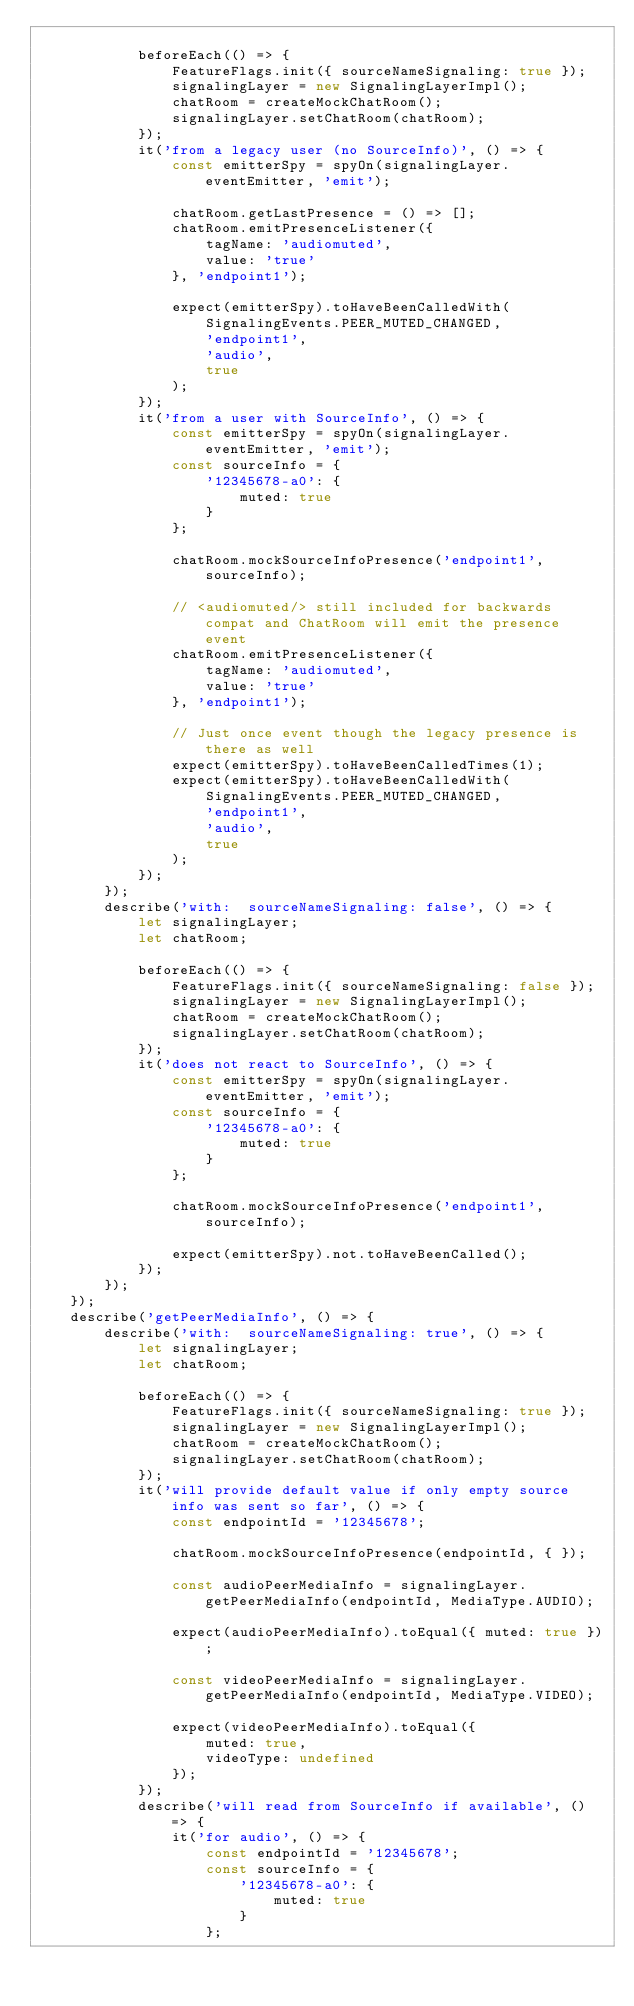<code> <loc_0><loc_0><loc_500><loc_500><_JavaScript_>
            beforeEach(() => {
                FeatureFlags.init({ sourceNameSignaling: true });
                signalingLayer = new SignalingLayerImpl();
                chatRoom = createMockChatRoom();
                signalingLayer.setChatRoom(chatRoom);
            });
            it('from a legacy user (no SourceInfo)', () => {
                const emitterSpy = spyOn(signalingLayer.eventEmitter, 'emit');

                chatRoom.getLastPresence = () => [];
                chatRoom.emitPresenceListener({
                    tagName: 'audiomuted',
                    value: 'true'
                }, 'endpoint1');

                expect(emitterSpy).toHaveBeenCalledWith(
                    SignalingEvents.PEER_MUTED_CHANGED,
                    'endpoint1',
                    'audio',
                    true
                );
            });
            it('from a user with SourceInfo', () => {
                const emitterSpy = spyOn(signalingLayer.eventEmitter, 'emit');
                const sourceInfo = {
                    '12345678-a0': {
                        muted: true
                    }
                };

                chatRoom.mockSourceInfoPresence('endpoint1', sourceInfo);

                // <audiomuted/> still included for backwards compat and ChatRoom will emit the presence event
                chatRoom.emitPresenceListener({
                    tagName: 'audiomuted',
                    value: 'true'
                }, 'endpoint1');

                // Just once event though the legacy presence is there as well
                expect(emitterSpy).toHaveBeenCalledTimes(1);
                expect(emitterSpy).toHaveBeenCalledWith(
                    SignalingEvents.PEER_MUTED_CHANGED,
                    'endpoint1',
                    'audio',
                    true
                );
            });
        });
        describe('with:  sourceNameSignaling: false', () => {
            let signalingLayer;
            let chatRoom;

            beforeEach(() => {
                FeatureFlags.init({ sourceNameSignaling: false });
                signalingLayer = new SignalingLayerImpl();
                chatRoom = createMockChatRoom();
                signalingLayer.setChatRoom(chatRoom);
            });
            it('does not react to SourceInfo', () => {
                const emitterSpy = spyOn(signalingLayer.eventEmitter, 'emit');
                const sourceInfo = {
                    '12345678-a0': {
                        muted: true
                    }
                };

                chatRoom.mockSourceInfoPresence('endpoint1', sourceInfo);

                expect(emitterSpy).not.toHaveBeenCalled();
            });
        });
    });
    describe('getPeerMediaInfo', () => {
        describe('with:  sourceNameSignaling: true', () => {
            let signalingLayer;
            let chatRoom;

            beforeEach(() => {
                FeatureFlags.init({ sourceNameSignaling: true });
                signalingLayer = new SignalingLayerImpl();
                chatRoom = createMockChatRoom();
                signalingLayer.setChatRoom(chatRoom);
            });
            it('will provide default value if only empty source info was sent so far', () => {
                const endpointId = '12345678';

                chatRoom.mockSourceInfoPresence(endpointId, { });

                const audioPeerMediaInfo = signalingLayer.getPeerMediaInfo(endpointId, MediaType.AUDIO);

                expect(audioPeerMediaInfo).toEqual({ muted: true });

                const videoPeerMediaInfo = signalingLayer.getPeerMediaInfo(endpointId, MediaType.VIDEO);

                expect(videoPeerMediaInfo).toEqual({
                    muted: true,
                    videoType: undefined
                });
            });
            describe('will read from SourceInfo if available', () => {
                it('for audio', () => {
                    const endpointId = '12345678';
                    const sourceInfo = {
                        '12345678-a0': {
                            muted: true
                        }
                    };
</code> 